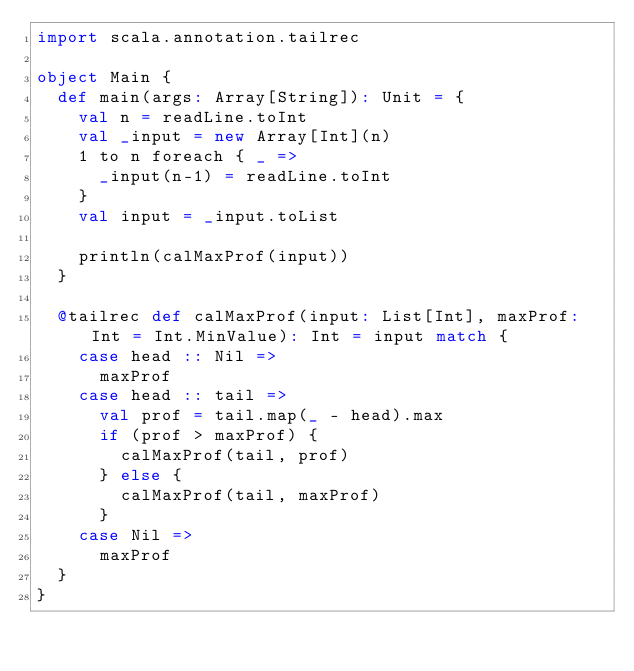<code> <loc_0><loc_0><loc_500><loc_500><_Scala_>import scala.annotation.tailrec

object Main {
  def main(args: Array[String]): Unit = {
    val n = readLine.toInt
    val _input = new Array[Int](n)
    1 to n foreach { _ =>
      _input(n-1) = readLine.toInt
    }
    val input = _input.toList

    println(calMaxProf(input))
  }

  @tailrec def calMaxProf(input: List[Int], maxProf: Int = Int.MinValue): Int = input match {
    case head :: Nil =>
      maxProf
    case head :: tail =>
      val prof = tail.map(_ - head).max
      if (prof > maxProf) {
        calMaxProf(tail, prof)
      } else {
        calMaxProf(tail, maxProf)
      }
    case Nil =>
      maxProf
  }
}

</code> 